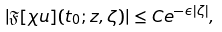<formula> <loc_0><loc_0><loc_500><loc_500>| \mathfrak { F } [ \chi u ] ( t _ { 0 } ; z , \zeta ) | \leq C e ^ { - \epsilon | \zeta | } ,</formula> 